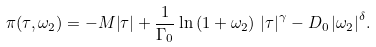Convert formula to latex. <formula><loc_0><loc_0><loc_500><loc_500>\pi ( \tau , \omega _ { 2 } ) = - M { \left | { \tau } \right | } + { \frac { 1 } { { \Gamma _ { 0 } } } } \ln \left ( { 1 + \omega _ { 2 } } \right ) \, { \left | { \tau } \right | } ^ { \gamma } - D _ { 0 } \, { \left | { \omega _ { 2 } } \right | } ^ { \delta } .</formula> 